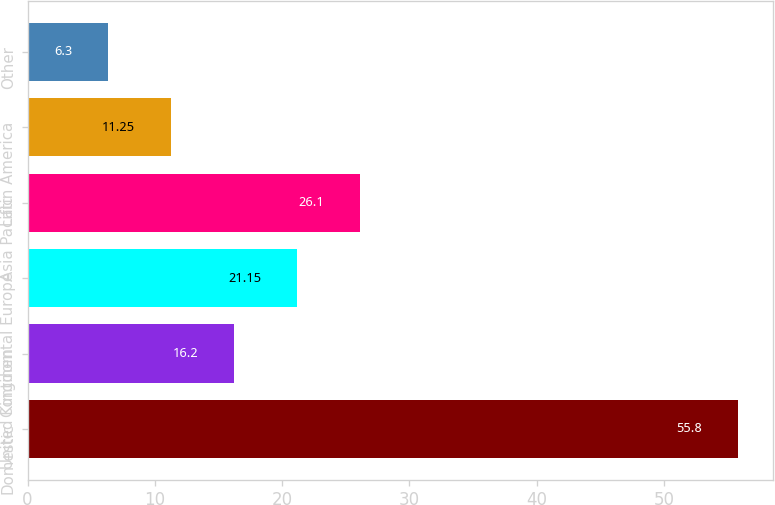Convert chart. <chart><loc_0><loc_0><loc_500><loc_500><bar_chart><fcel>Domestic<fcel>United Kingdom<fcel>Continental Europe<fcel>Asia Pacific<fcel>Latin America<fcel>Other<nl><fcel>55.8<fcel>16.2<fcel>21.15<fcel>26.1<fcel>11.25<fcel>6.3<nl></chart> 